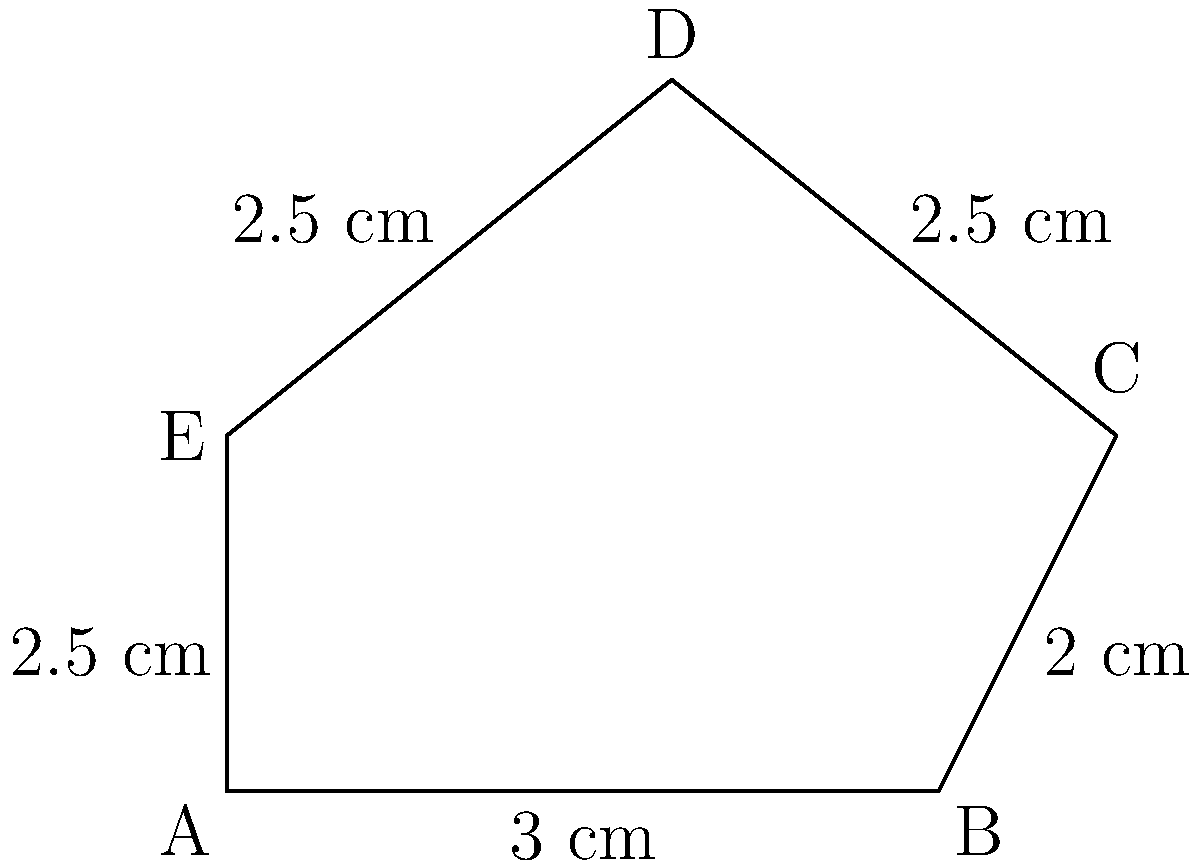A traditional Nigerian Aso Oke fabric design features a pentagonal pattern. The sides of the pentagon measure 3 cm, 2 cm, 2.5 cm, 2.5 cm, and 2.5 cm, as shown in the diagram. Calculate the perimeter of this pentagonal design. To calculate the perimeter of the pentagonal Aso Oke fabric design, we need to sum up the lengths of all sides. Let's follow these steps:

1. Identify the lengths of each side:
   Side AB = 3 cm
   Side BC = 2 cm
   Side CD = 2.5 cm
   Side DE = 2.5 cm
   Side EA = 2.5 cm

2. Add up all the side lengths:
   Perimeter = AB + BC + CD + DE + EA
   Perimeter = 3 cm + 2 cm + 2.5 cm + 2.5 cm + 2.5 cm

3. Perform the addition:
   Perimeter = 12.5 cm

Therefore, the perimeter of the pentagonal Aso Oke fabric design is 12.5 cm.
Answer: 12.5 cm 